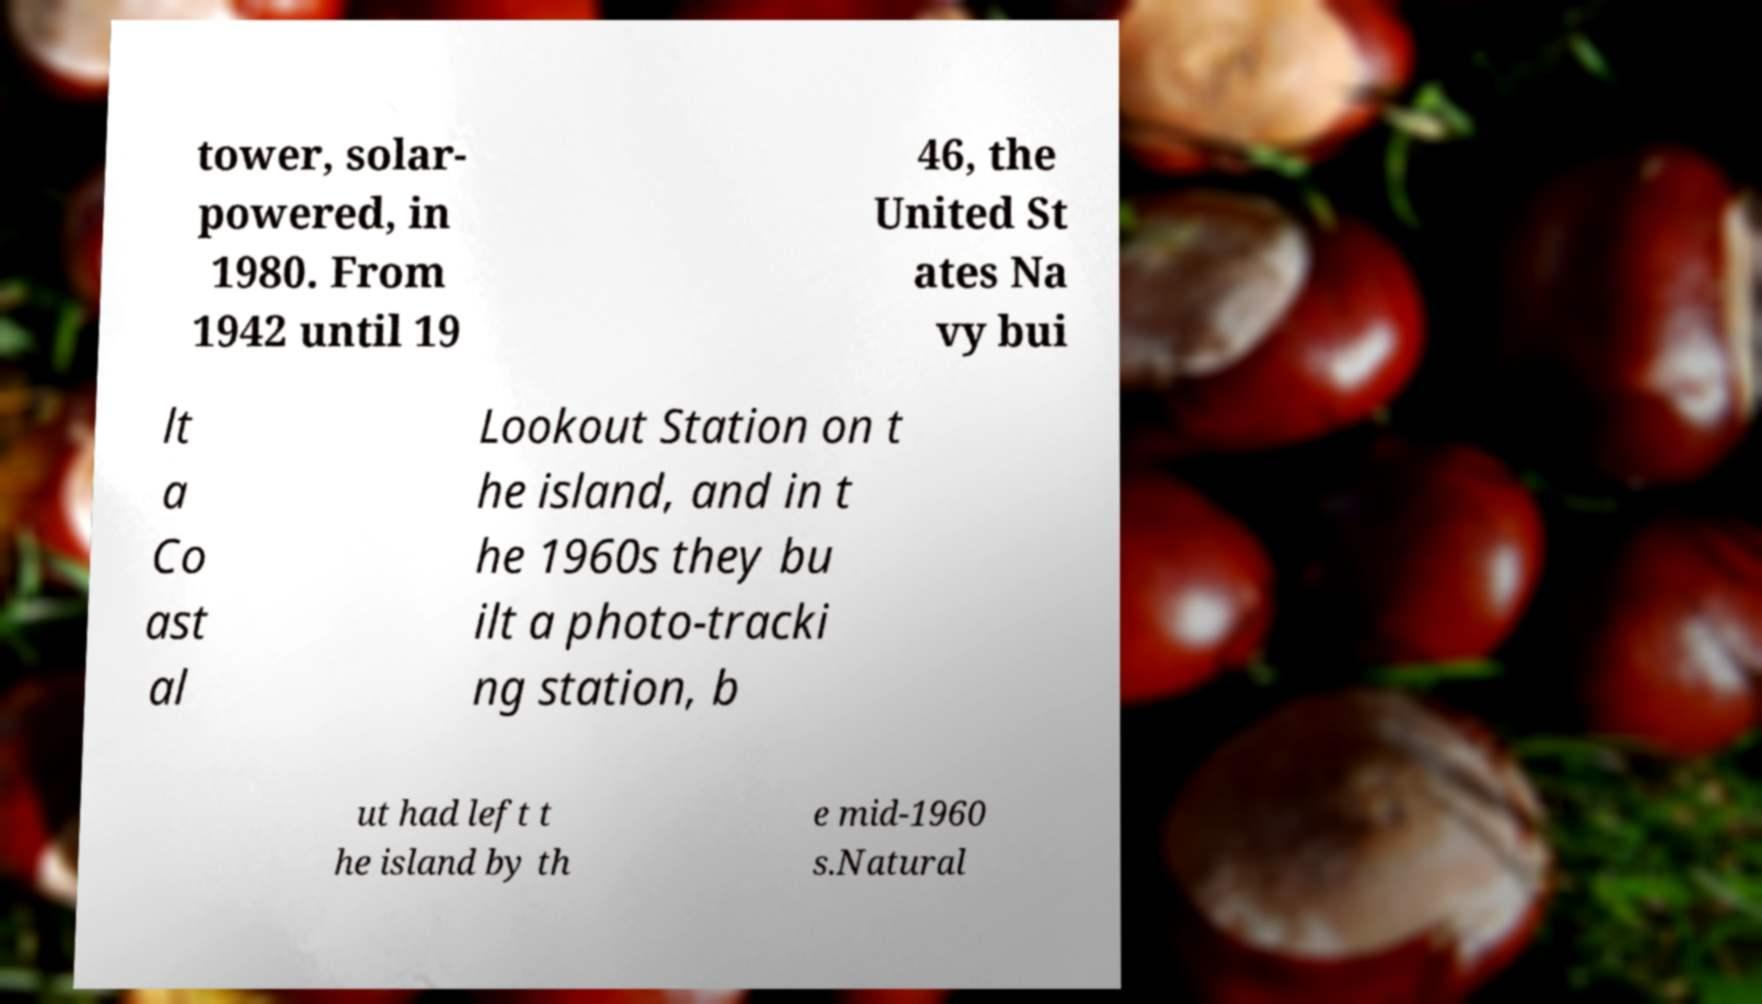I need the written content from this picture converted into text. Can you do that? tower, solar- powered, in 1980. From 1942 until 19 46, the United St ates Na vy bui lt a Co ast al Lookout Station on t he island, and in t he 1960s they bu ilt a photo-tracki ng station, b ut had left t he island by th e mid-1960 s.Natural 